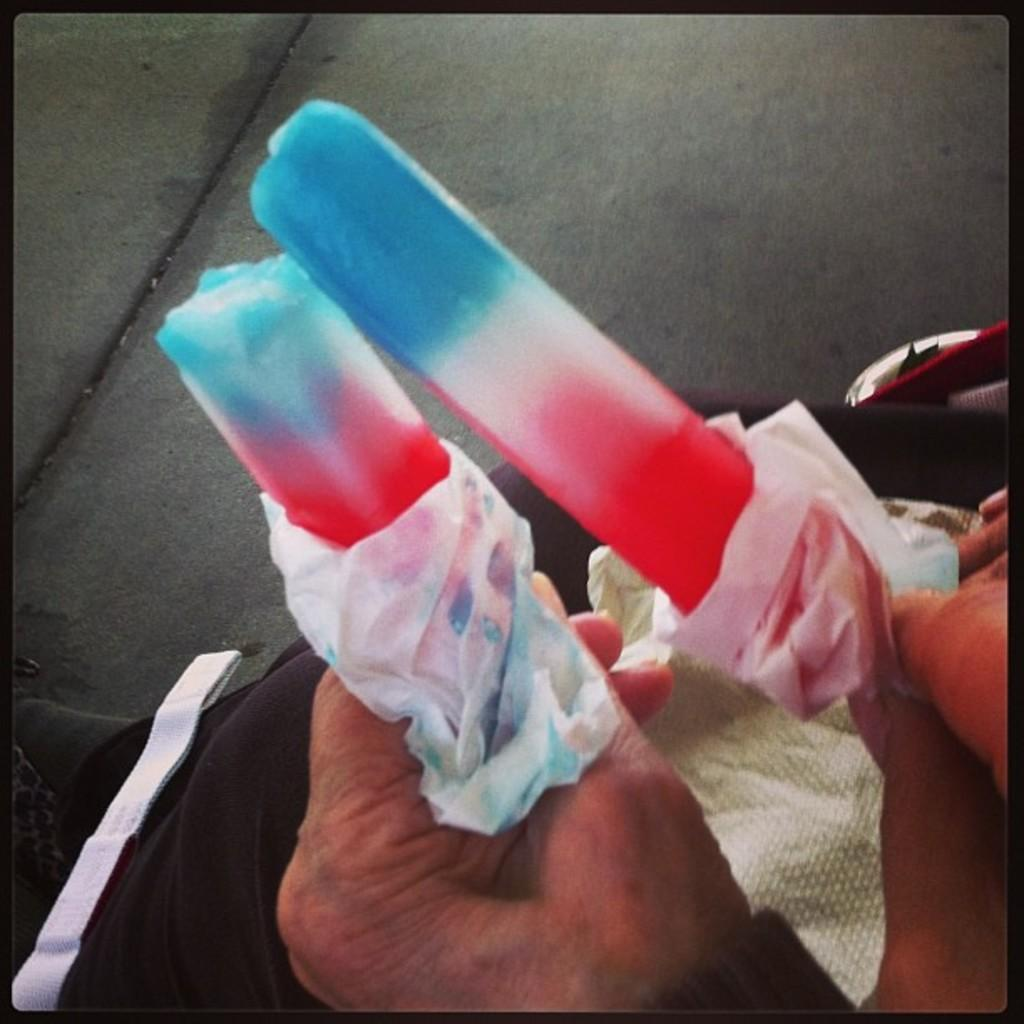Who is present in the image? There is a person in the image. What is the person holding in the image? The person is holding multi-colored ice creams. What type of soup is being served at the feast in the image? There is no feast or soup present in the image; it features a person holding multi-colored ice creams. What is inside the bag that the person is carrying in the image? There is no bag present in the image. 